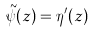<formula> <loc_0><loc_0><loc_500><loc_500>\tilde { \psi } ( z ) = \eta ^ { \prime } ( z )</formula> 